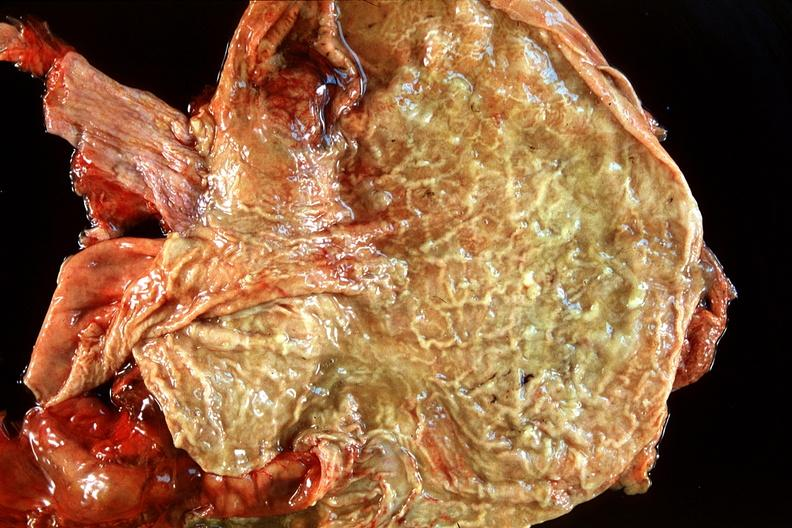what does this image show?
Answer the question using a single word or phrase. Normal stomach 